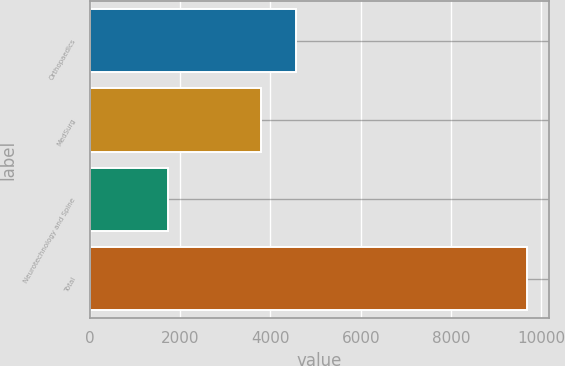<chart> <loc_0><loc_0><loc_500><loc_500><bar_chart><fcel>Orthopaedics<fcel>MedSurg<fcel>Neurotechnology and Spine<fcel>Total<nl><fcel>4574.4<fcel>3781<fcel>1741<fcel>9675<nl></chart> 